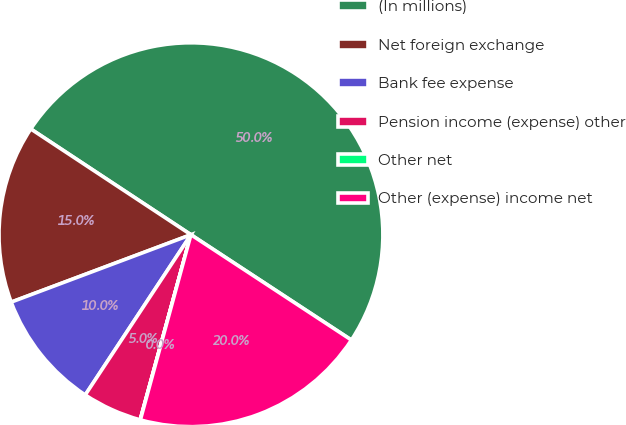<chart> <loc_0><loc_0><loc_500><loc_500><pie_chart><fcel>(In millions)<fcel>Net foreign exchange<fcel>Bank fee expense<fcel>Pension income (expense) other<fcel>Other net<fcel>Other (expense) income net<nl><fcel>49.96%<fcel>15.0%<fcel>10.01%<fcel>5.02%<fcel>0.02%<fcel>20.0%<nl></chart> 